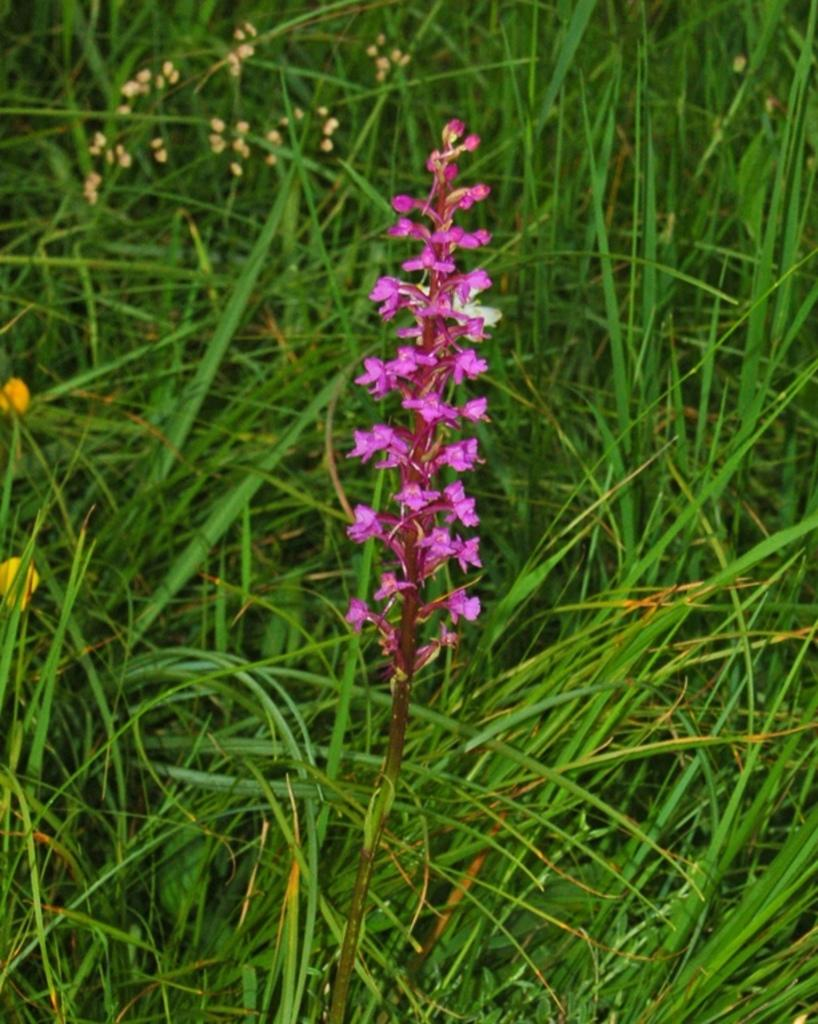What is the main subject in the center of the image? There is a flower plant in the center of the image. What can be seen in the background of the image? There is greenery in the background of the image. What month is the goose enjoying its vacation in the image? There is no goose or vacation present in the image; it features a flower plant and greenery. 